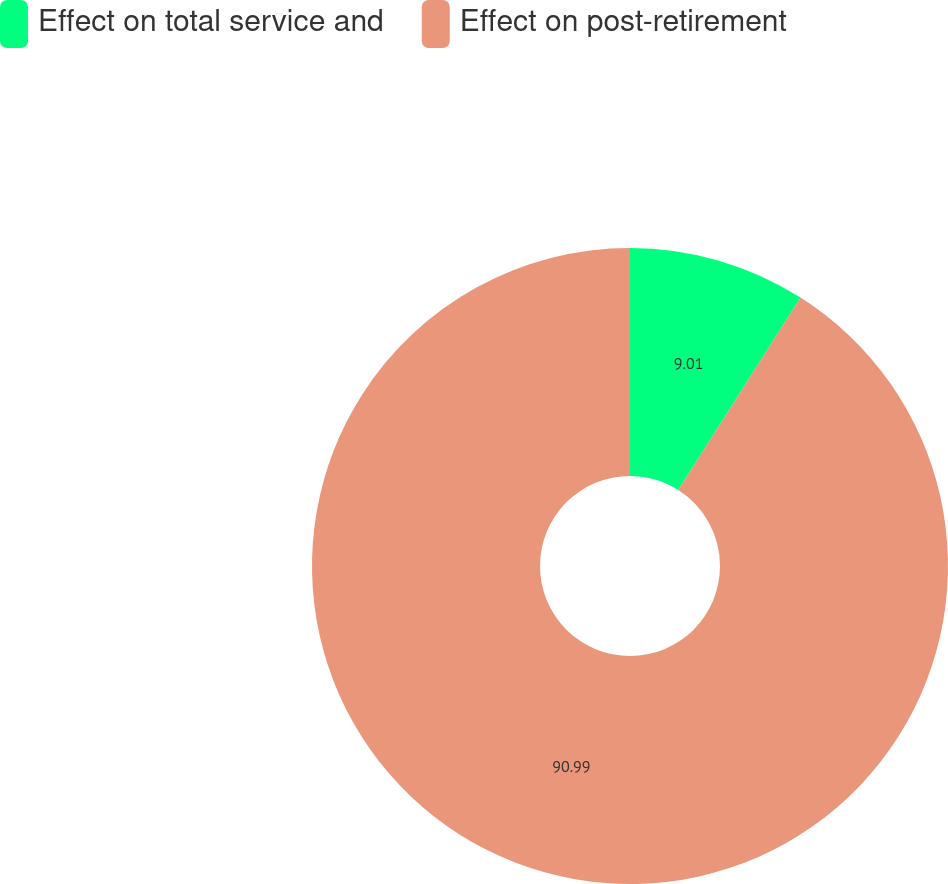<chart> <loc_0><loc_0><loc_500><loc_500><pie_chart><fcel>Effect on total service and<fcel>Effect on post-retirement<nl><fcel>9.01%<fcel>90.99%<nl></chart> 